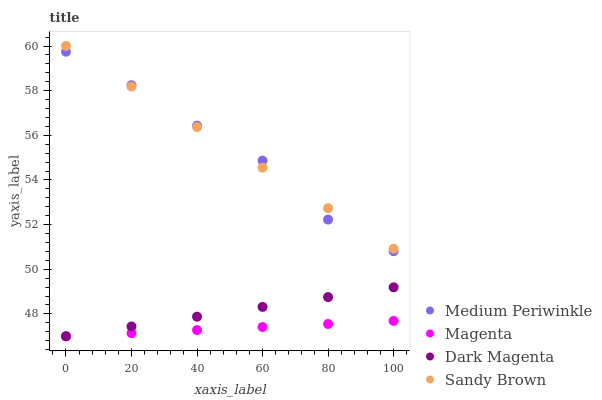Does Magenta have the minimum area under the curve?
Answer yes or no. Yes. Does Sandy Brown have the maximum area under the curve?
Answer yes or no. Yes. Does Medium Periwinkle have the minimum area under the curve?
Answer yes or no. No. Does Medium Periwinkle have the maximum area under the curve?
Answer yes or no. No. Is Sandy Brown the smoothest?
Answer yes or no. Yes. Is Medium Periwinkle the roughest?
Answer yes or no. Yes. Is Magenta the smoothest?
Answer yes or no. No. Is Magenta the roughest?
Answer yes or no. No. Does Magenta have the lowest value?
Answer yes or no. Yes. Does Medium Periwinkle have the lowest value?
Answer yes or no. No. Does Sandy Brown have the highest value?
Answer yes or no. Yes. Does Medium Periwinkle have the highest value?
Answer yes or no. No. Is Dark Magenta less than Medium Periwinkle?
Answer yes or no. Yes. Is Sandy Brown greater than Dark Magenta?
Answer yes or no. Yes. Does Medium Periwinkle intersect Sandy Brown?
Answer yes or no. Yes. Is Medium Periwinkle less than Sandy Brown?
Answer yes or no. No. Is Medium Periwinkle greater than Sandy Brown?
Answer yes or no. No. Does Dark Magenta intersect Medium Periwinkle?
Answer yes or no. No. 